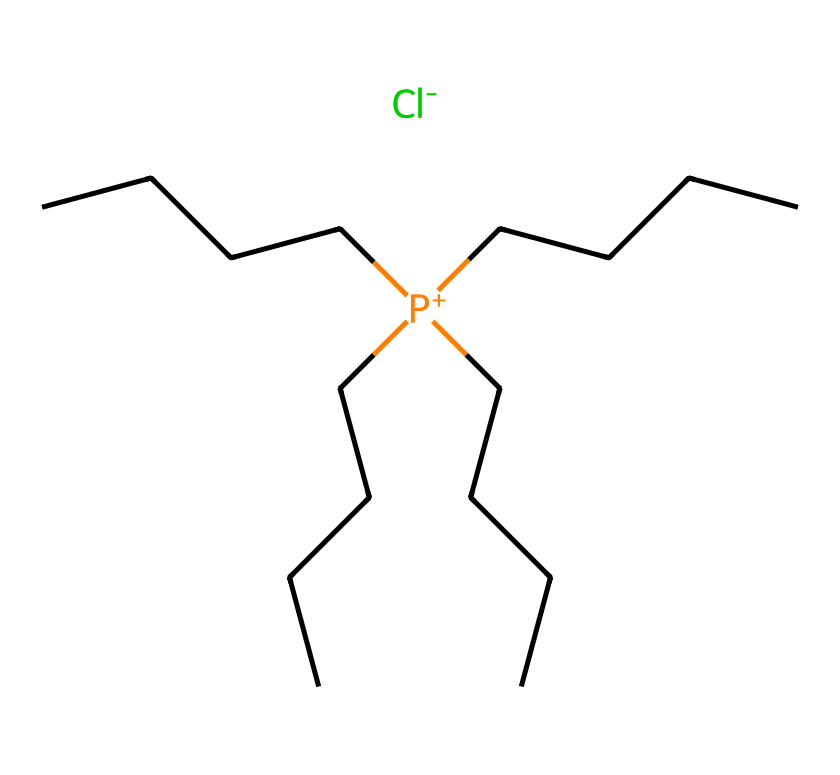What is the central atom in the ionic liquid? The structure shows a phosphorus atom (P) at the center, indicated by its positive charge and connectivity to multiple carbon chains.
Answer: phosphorus How many carbon atoms are present in this ionic liquid? The structure features four long carbon chains (CCCC), each consisting of four carbon atoms, leading to a total of 16 carbon atoms (4 chains x 4 carbons).
Answer: 16 What is the anion associated with this ionic liquid? The chemical structure contains the notation “.[Cl-]” at the end, indicating that the chloride ion (Cl-) is the associated anion in this ionic liquid.
Answer: chloride What is the charge of the phosphonium ion? The central phosphorus atom is designated with a positive charge, indicated by the "P+" notation, which confirms its identity as a phosphonium ion.
Answer: positive Why might this phosphonium ionic liquid be considered a potential antiviral agent? Phosphonium ionic liquids can have unique interaction properties with viral proteins, such as disrupting viral entry mechanisms due to their charge and structure, thus exhibiting antiviral properties.
Answer: unique interaction properties What type of structure does this ionic liquid possess? The ionic liquid exhibits a symmetrical layout due to the long hydrocarbon chains attached to the central phosphonium ion, characteristic of a liquid at room temperature.
Answer: symmetrical layout How many total atoms (including ions) are in this ionic liquid? The structure includes 1 phosphorus atom, 16 carbon atoms, and 1 chlorine atom, resulting in a total of 18 atoms (1 + 16 + 1).
Answer: 18 